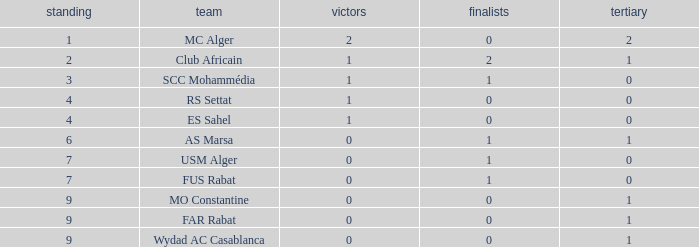Which Rank has a Third of 2, and Winners smaller than 2? None. Can you parse all the data within this table? {'header': ['standing', 'team', 'victors', 'finalists', 'tertiary'], 'rows': [['1', 'MC Alger', '2', '0', '2'], ['2', 'Club Africain', '1', '2', '1'], ['3', 'SCC Mohammédia', '1', '1', '0'], ['4', 'RS Settat', '1', '0', '0'], ['4', 'ES Sahel', '1', '0', '0'], ['6', 'AS Marsa', '0', '1', '1'], ['7', 'USM Alger', '0', '1', '0'], ['7', 'FUS Rabat', '0', '1', '0'], ['9', 'MO Constantine', '0', '0', '1'], ['9', 'FAR Rabat', '0', '0', '1'], ['9', 'Wydad AC Casablanca', '0', '0', '1']]} 